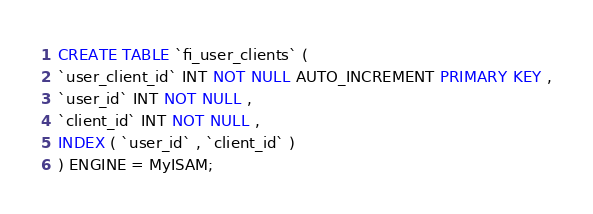Convert code to text. <code><loc_0><loc_0><loc_500><loc_500><_SQL_>CREATE TABLE `fi_user_clients` (
`user_client_id` INT NOT NULL AUTO_INCREMENT PRIMARY KEY ,
`user_id` INT NOT NULL ,
`client_id` INT NOT NULL ,
INDEX ( `user_id` , `client_id` )
) ENGINE = MyISAM;</code> 